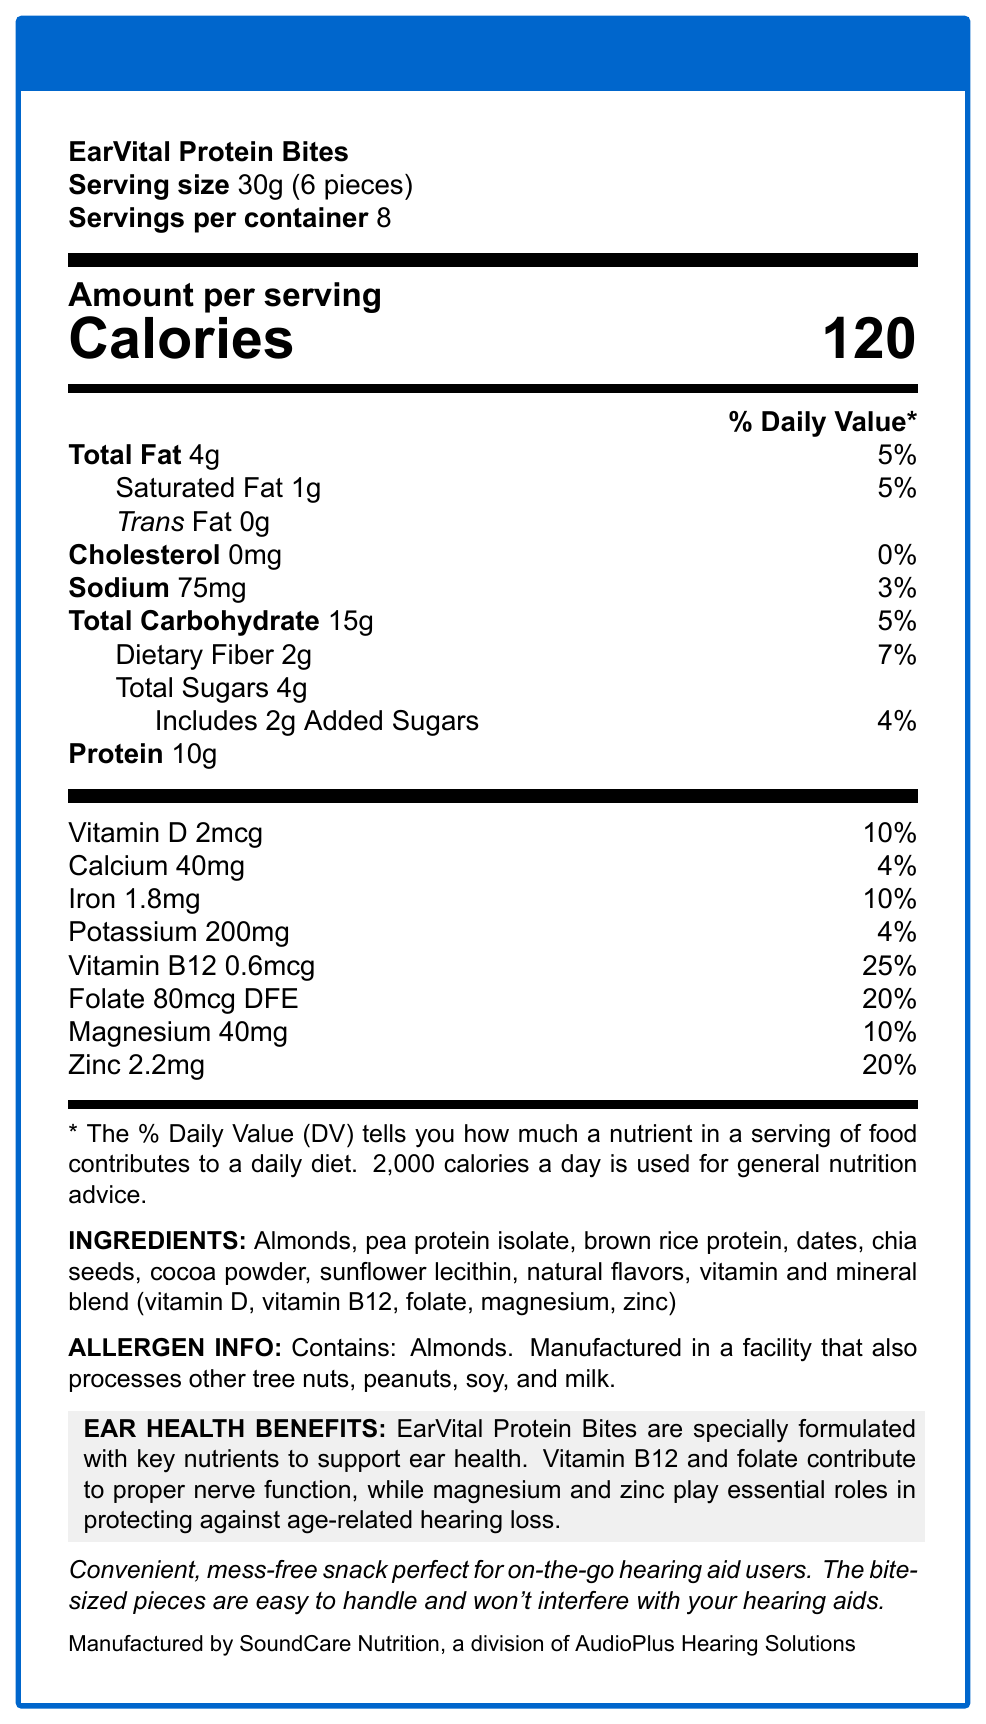what is the serving size of EarVital Protein Bites? The serving size is directly mentioned in the document, which states it as 30g (6 pieces).
Answer: 30g (6 pieces) how many servings are there per container? The document clearly mentions that there are 8 servings per container.
Answer: 8 how many calories are in one serving? The document states that there are 120 calories per serving.
Answer: 120 what is the amount of vitamin B12 in one serving, and what is its % Daily Value? The document lists vitamin B12 with an amount of 0.6mcg and a % Daily Value of 25%.
Answer: 0.6mcg, 25% which ingredients are included in the vitamin and mineral blend? The document lists the specific vitamins and minerals in the blend within the ingredients section.
Answer: vitamin D, vitamin B12, folate, magnesium, zinc what type of fat does EarVital Protein Bites contain and in what amounts? The document specifies the different types of fats and their amounts: Total Fat is 4g, Saturated Fat is 1g, and Trans Fat is 0g.
Answer: Total Fat: 4g, Saturated Fat: 1g, Trans Fat: 0g what nutrients are provided for ear health, according to the document? The ear health benefits section mentions Vitamin B12, Folate, Magnesium, and Zinc as key nutrients for ear health.
Answer: Vitamin B12, Folate, Magnesium, Zinc where is EarVital Protein Bites manufactured? The document specifies the manufacturer as SoundCare Nutrition, a division of AudioPlus Hearing Solutions.
Answer: SoundCare Nutrition, a division of AudioPlus Hearing Solutions does EarVital Protein Bites contain any allergens? The allergen information states that EarVital Protein Bites contain almonds and are manufactured in a facility that processes other tree nuts, peanuts, soy, and milk.
Answer: Yes are EarVital Protein Bites a good snack option for hearing aid users? The document mentions that EarVital Protein Bites are convenient and mess-free, making them suitable for on-the-go hearing aid users.
Answer: Yes what is the calorie contribution from a serving of EarVital Protein Bites?  
A. 80 calories  
B. 100 calories  
C. 120 calories  
D. 140 calories The document states that each serving provides 120 calories.
Answer: C which of the following vitamins contributes the most to the % Daily Value in one serving?  
i. Vitamin D  
ii. Folate  
iii. Zinc  
iv. Vitamin B12 Vitamin B12 contributes 25% to the % Daily Value per serving, which is higher than the other listed vitamins.
Answer: iv. Vitamin B12 is the sodium content in EarVital Protein Bites high compared to the % Daily Value? The sodium content is 75mg, which is 3% of the Daily Value, indicating a low sodium content.
Answer: No summarize the main idea of this document. The document focuses on providing detailed nutritional information, ingredients, allergen warnings, and specific benefits for ear health, promoting the snack as ideal for hearing aid users.
Answer: EarVital Protein Bites are a protein-rich snack designed for convenience and ear health, containing key vitamins and minerals like Vitamin B12, folate, magnesium, and zinc. Each serving has 120 calories and key nutrients that contribute to proper nerve function and protection against hearing loss. The bites are also labeled with allergen and convenience information relevant to hearing aid users. how much protein is in a full container of EarVital Protein Bites? The document provides the amount of protein per serving (10g) but doesn't explicitly state the total protein content for the entire container or the calculation for all servings combined.
Answer: Cannot be determined 